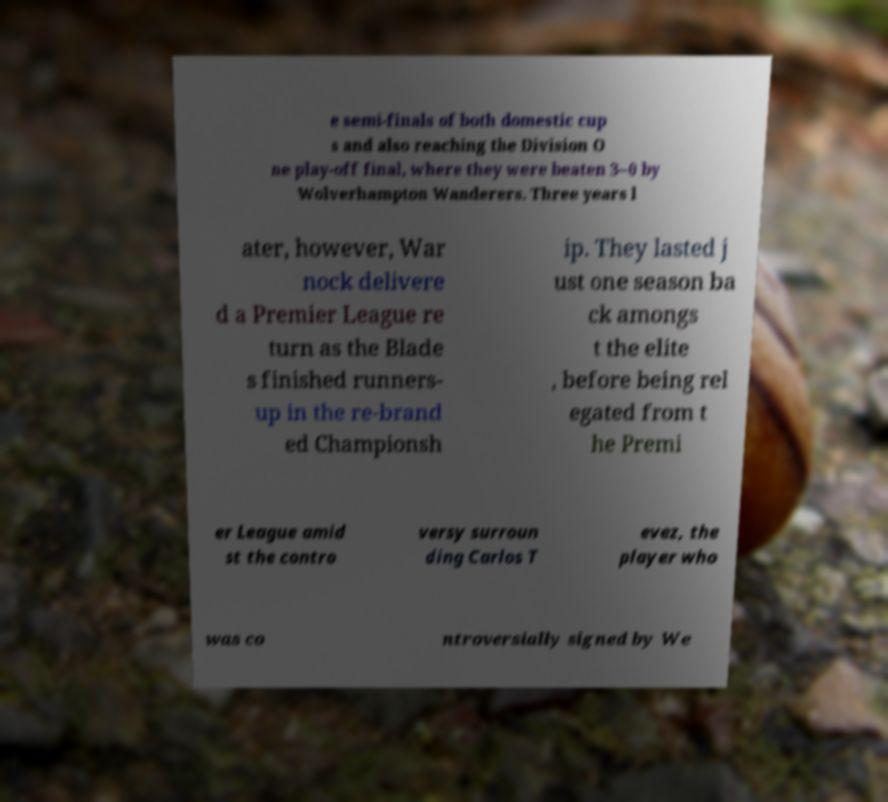Please read and relay the text visible in this image. What does it say? e semi-finals of both domestic cup s and also reaching the Division O ne play-off final, where they were beaten 3–0 by Wolverhampton Wanderers. Three years l ater, however, War nock delivere d a Premier League re turn as the Blade s finished runners- up in the re-brand ed Championsh ip. They lasted j ust one season ba ck amongs t the elite , before being rel egated from t he Premi er League amid st the contro versy surroun ding Carlos T evez, the player who was co ntroversially signed by We 